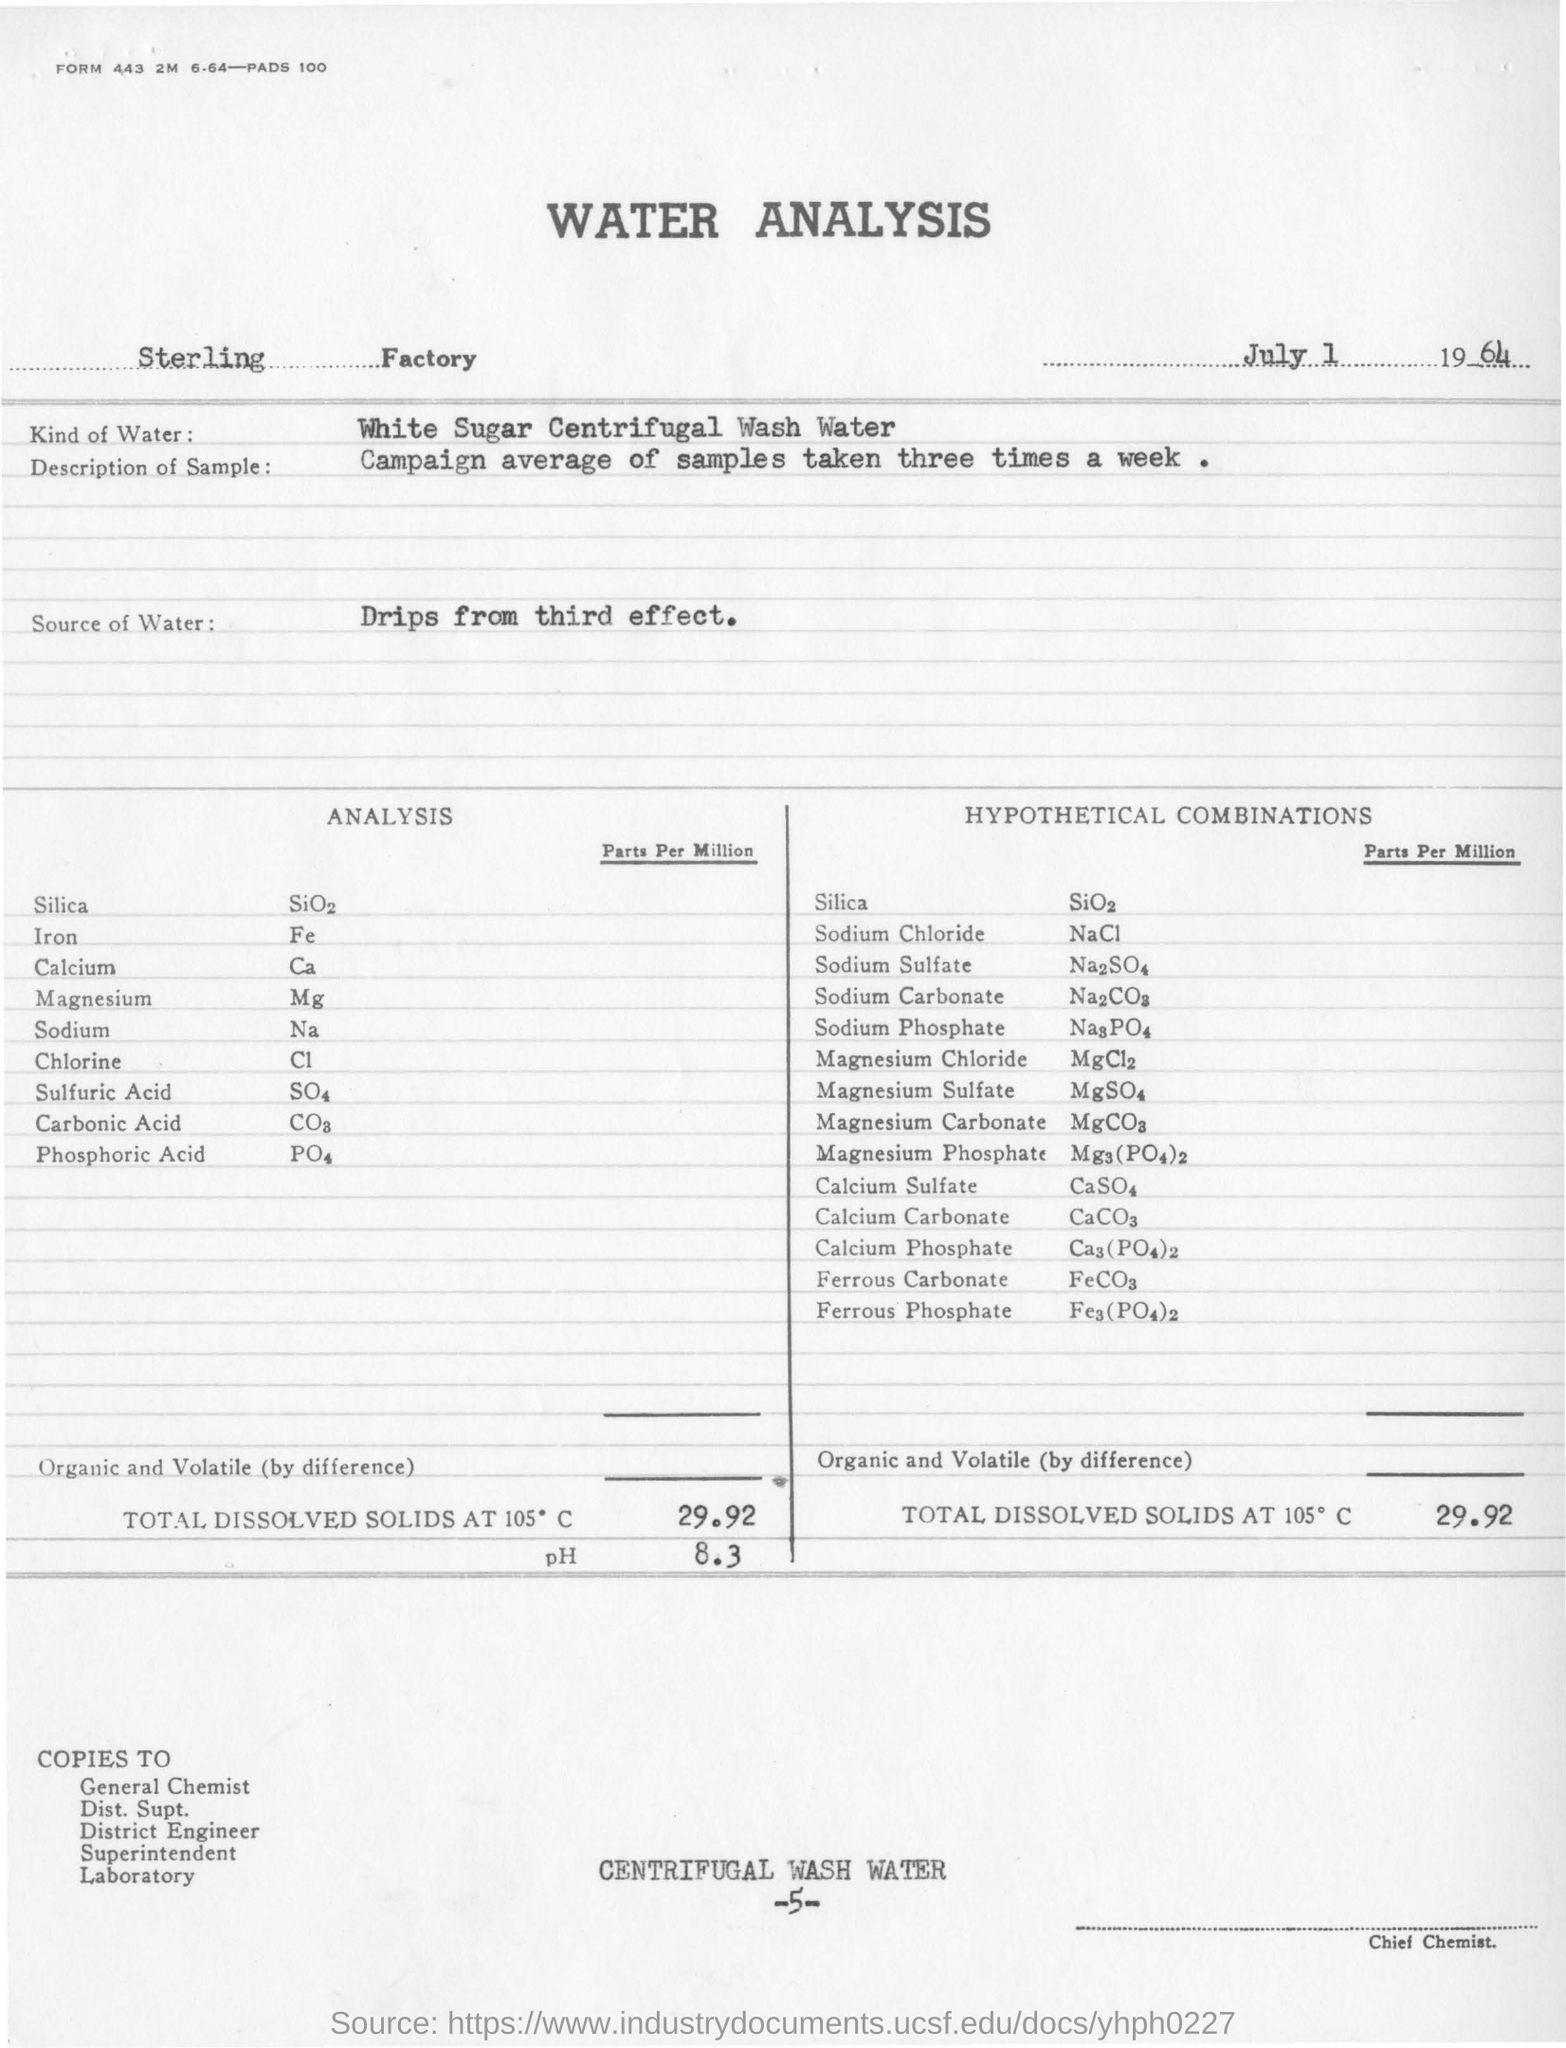Point out several critical features in this image. The source of water for analysis is drips from the third effect. The pH value maintained for water analysis is 8.3. Sterling Factory conducts the water analysis. The sample taken was described as part of a campaign that was taken three times a week on average. The type of water used for analysis is white sugar centrifugal wash water. 